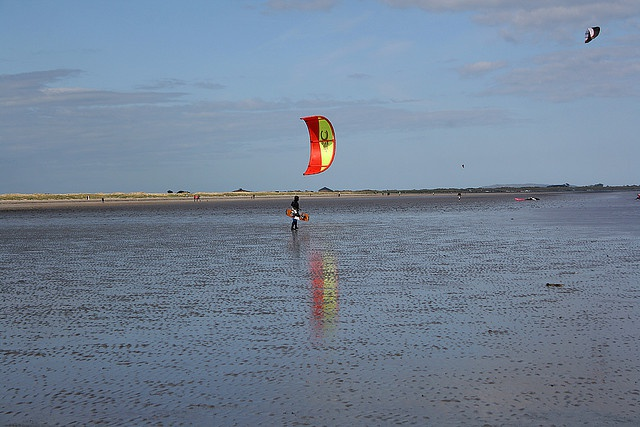Describe the objects in this image and their specific colors. I can see kite in gray, red, maroon, and khaki tones, people in gray, black, darkgray, and white tones, kite in gray, black, darkgray, and lightgray tones, people in gray and black tones, and people in gray, lightgray, and black tones in this image. 